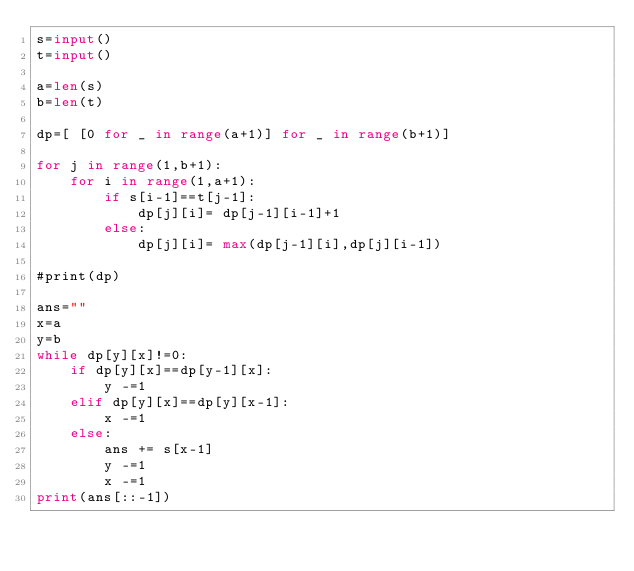<code> <loc_0><loc_0><loc_500><loc_500><_Python_>s=input()
t=input()

a=len(s)
b=len(t)

dp=[ [0 for _ in range(a+1)] for _ in range(b+1)]

for j in range(1,b+1):
    for i in range(1,a+1):
        if s[i-1]==t[j-1]:
            dp[j][i]= dp[j-1][i-1]+1
        else:
            dp[j][i]= max(dp[j-1][i],dp[j][i-1])

#print(dp)

ans=""
x=a
y=b
while dp[y][x]!=0:
    if dp[y][x]==dp[y-1][x]:
        y -=1
    elif dp[y][x]==dp[y][x-1]:
        x -=1
    else:
        ans += s[x-1]
        y -=1
        x -=1
print(ans[::-1])</code> 